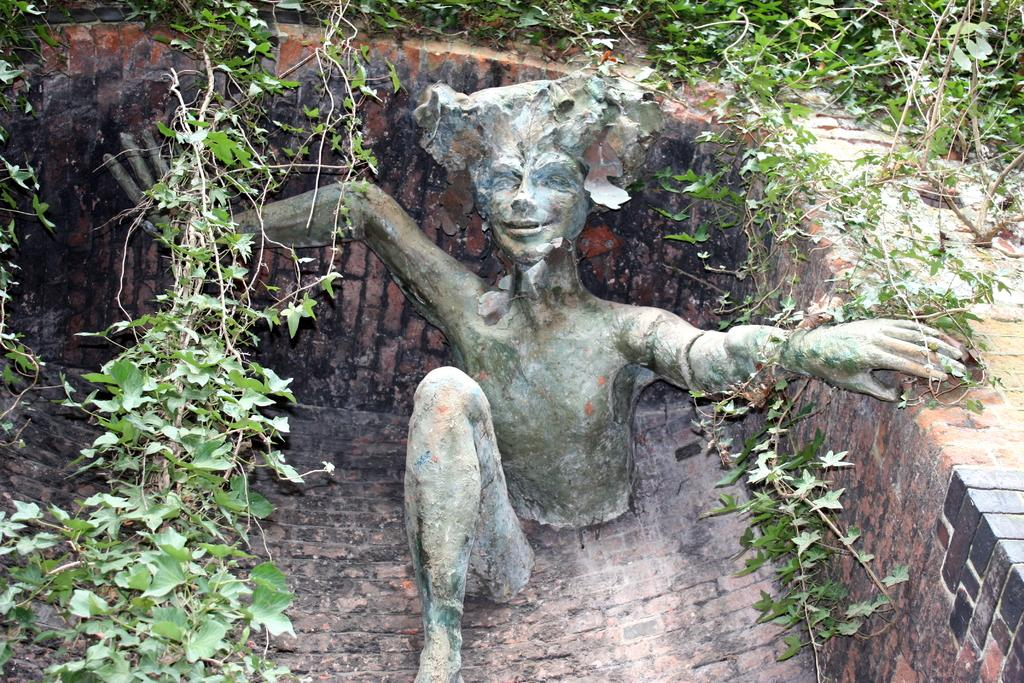What is the main subject of the image? There is a sculpture in the image. What can be seen in the background of the image? There is a wall in the image. Are there any natural elements present in the image? Yes, there is a plant in the image. What is the taste of the sidewalk in the image? There is no sidewalk present in the image, and therefore no taste can be associated with it. 